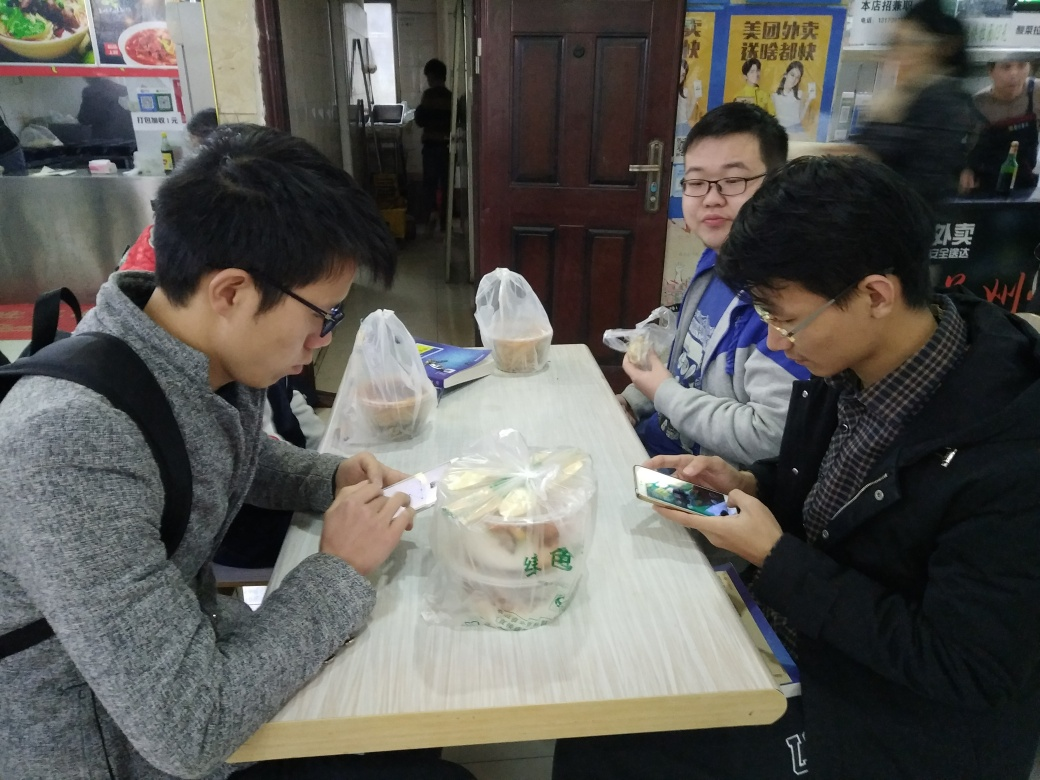Can you describe the atmosphere of the place where the individuals are seated? The place where the individuals are seated gives off a utilitarian and informal vibe typical of a fast-food restaurant or a casual eatery. The visible kitchen equipment in the background suggests that the establishment could be a small diner or a local food joint where people come for quick meals. Plastic bags with more food items on the table also indicate a take-out or self-service scenario. The atmosphere is not luxurious but has a practical and straightforward ambiance, primarily catering to the purpose of dining. 